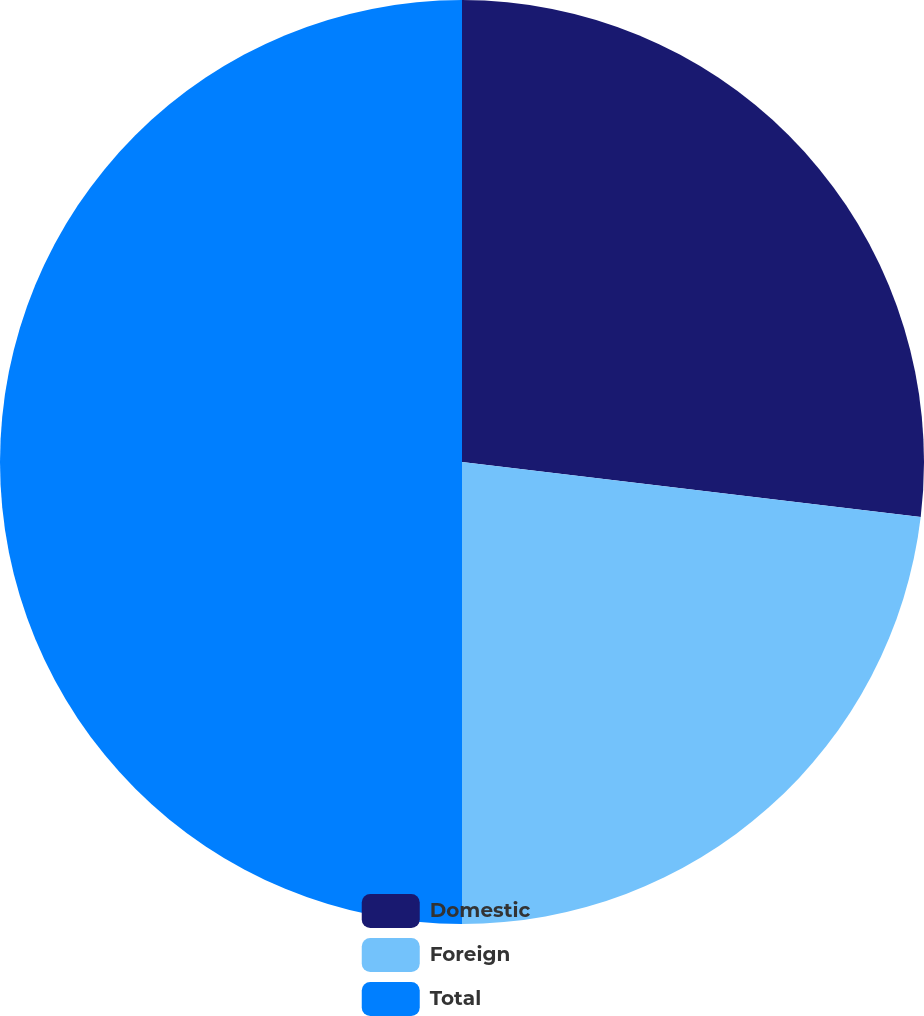<chart> <loc_0><loc_0><loc_500><loc_500><pie_chart><fcel>Domestic<fcel>Foreign<fcel>Total<nl><fcel>26.9%<fcel>23.1%<fcel>50.0%<nl></chart> 